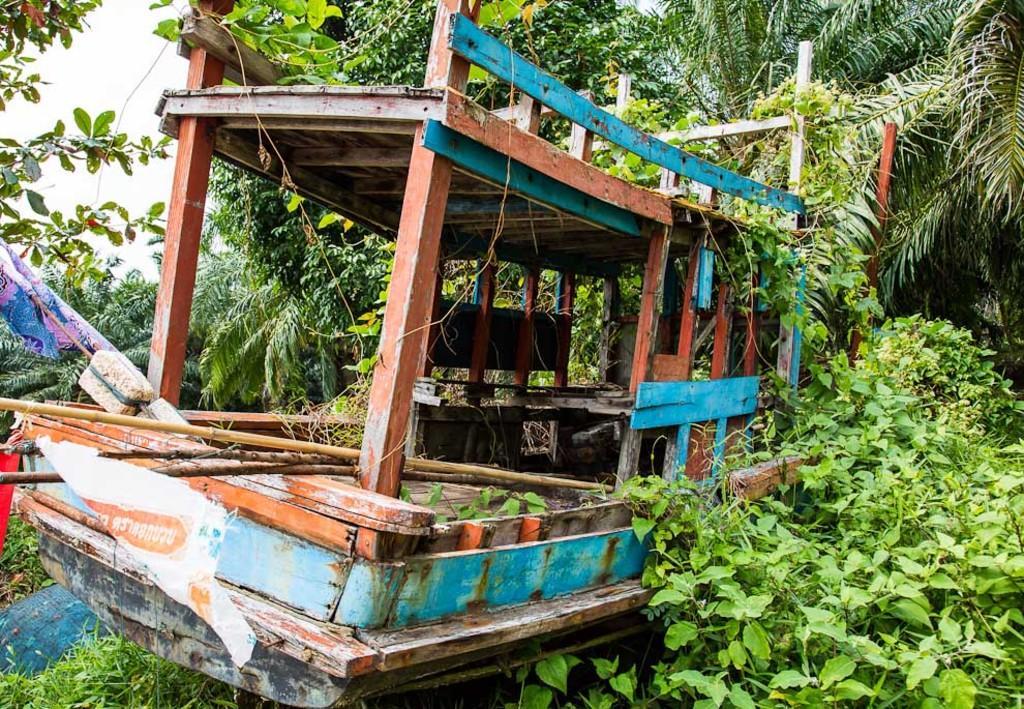Describe this image in one or two sentences. In the image there are many trees. In the middle of the image there is a boat with wooden poles, stones and some other things. 